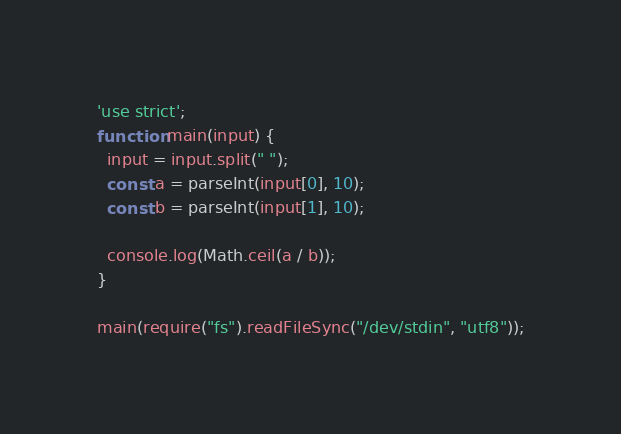Convert code to text. <code><loc_0><loc_0><loc_500><loc_500><_JavaScript_>'use strict';
function main(input) {
  input = input.split(" ");
  const a = parseInt(input[0], 10);
  const b = parseInt(input[1], 10);
  
  console.log(Math.ceil(a / b));
}

main(require("fs").readFileSync("/dev/stdin", "utf8"));</code> 